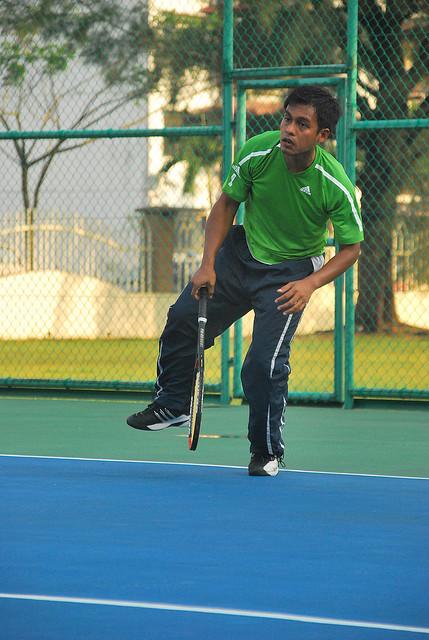Is tennis a highly physical sport?
Short answer required. Yes. Is the person standing up straight?
Short answer required. No. What color is the man's shirt?
Write a very short answer. Green. 